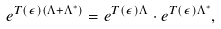<formula> <loc_0><loc_0><loc_500><loc_500>e ^ { T ( \epsilon ) ( \Lambda + \Lambda ^ { * } ) } = e ^ { T ( \epsilon ) \Lambda } \cdot e ^ { T ( \epsilon ) \Lambda ^ { * } } ,</formula> 